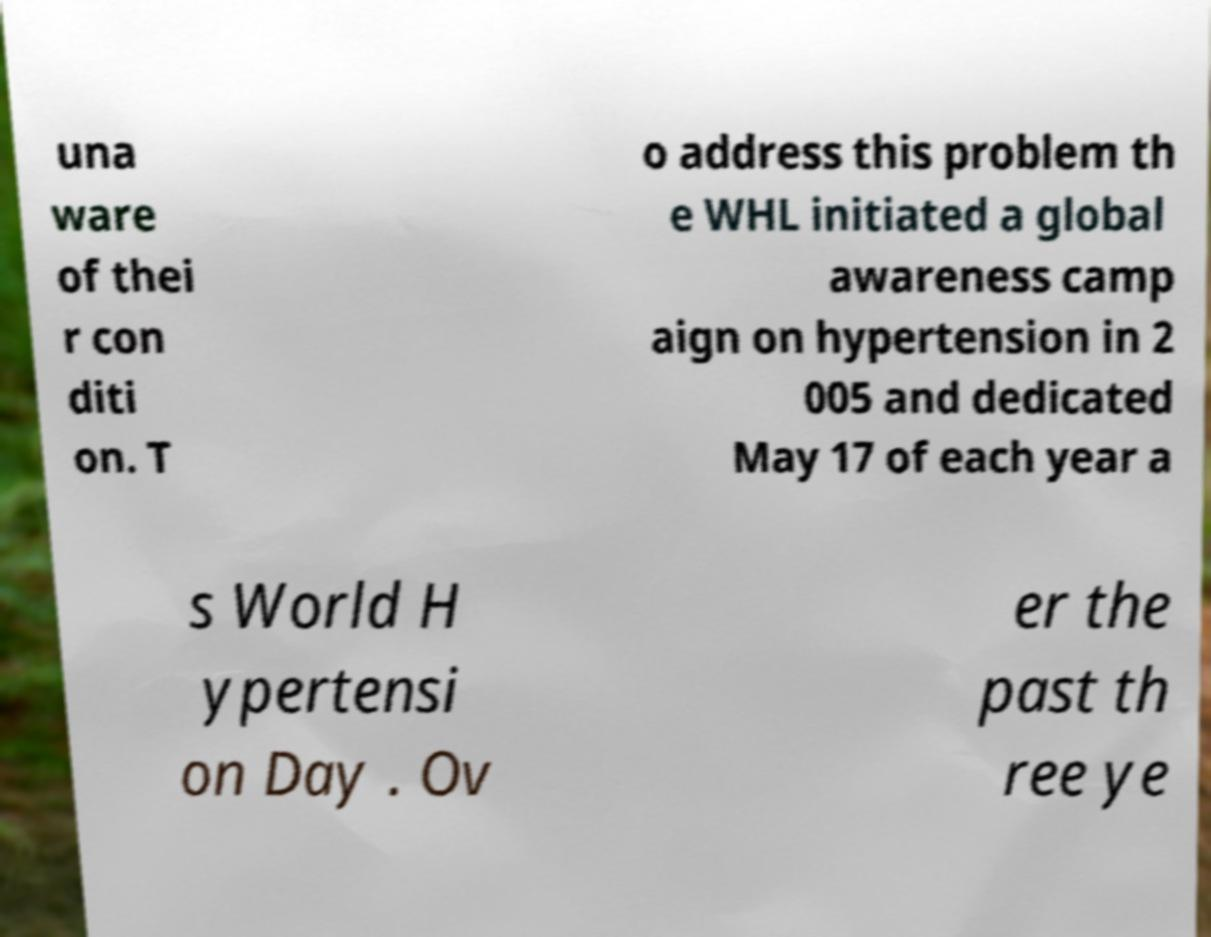For documentation purposes, I need the text within this image transcribed. Could you provide that? una ware of thei r con diti on. T o address this problem th e WHL initiated a global awareness camp aign on hypertension in 2 005 and dedicated May 17 of each year a s World H ypertensi on Day . Ov er the past th ree ye 